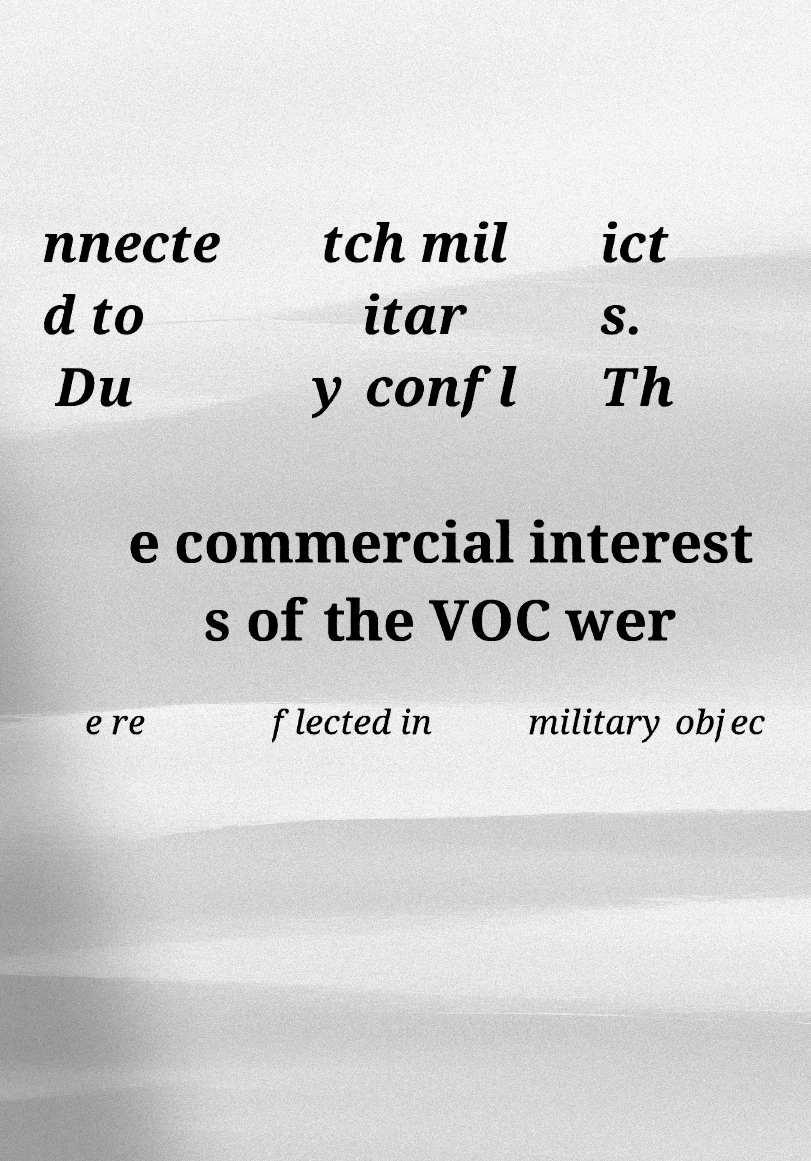For documentation purposes, I need the text within this image transcribed. Could you provide that? nnecte d to Du tch mil itar y confl ict s. Th e commercial interest s of the VOC wer e re flected in military objec 